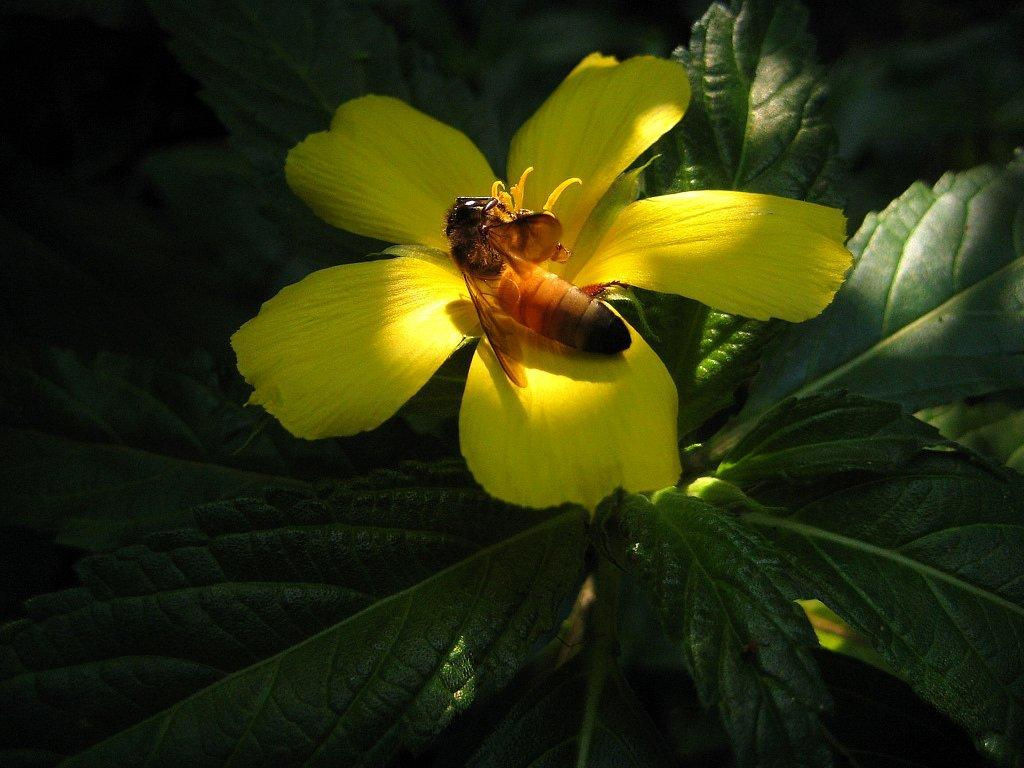What color is the flower on the plant in the image? The flower on the plant is yellow. What is present on the flower in the image? There is an insect on the flower. How much money does the flower earn in a week in the image? There is no mention of money or earnings in the image, as it features a yellow flower with an insect on it. 